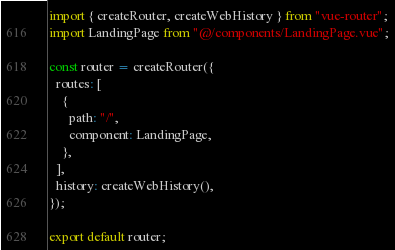Convert code to text. <code><loc_0><loc_0><loc_500><loc_500><_JavaScript_>import { createRouter, createWebHistory } from "vue-router";
import LandingPage from "@/components/LandingPage.vue";

const router = createRouter({
  routes: [
    {
      path: "/",
      component: LandingPage,
    },
  ],
  history: createWebHistory(),
});

export default router;
</code> 